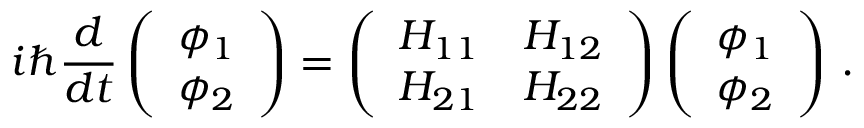Convert formula to latex. <formula><loc_0><loc_0><loc_500><loc_500>i \hbar { } d } { d t } \left ( \begin{array} { l } { \phi _ { 1 } } \\ { \phi _ { 2 } } \end{array} \right ) = \left ( \begin{array} { l l } { H _ { 1 1 } } & { H _ { 1 2 } } \\ { H _ { 2 1 } } & { H _ { 2 2 } } \end{array} \right ) \left ( \begin{array} { l } { \phi _ { 1 } } \\ { \phi _ { 2 } } \end{array} \right ) \, .</formula> 